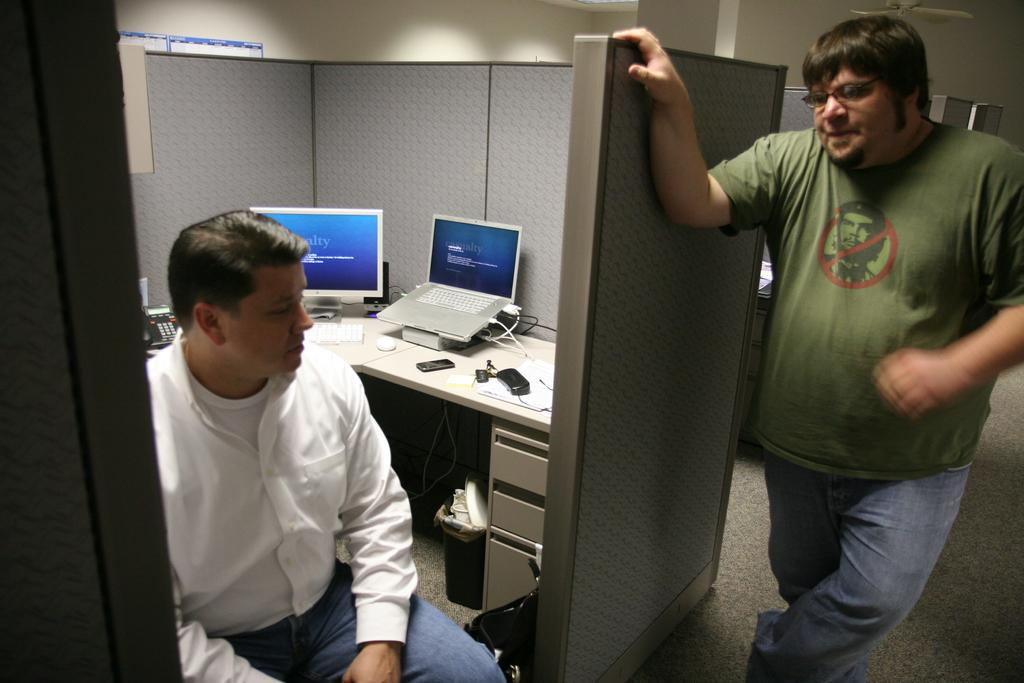What is the position of the first man in the image? The first man is sitting on a chair in the image. What is the position of the second man in the image? The second man is standing in the image. What piece of furniture is present in the image? There is a table in the image. What electronic devices are on the table? There is a monitor and a laptop on the table. What type of wool is being used to create the hill in the image? There is no hill or wool present in the image; it features two men, a table, a monitor, and a laptop. 